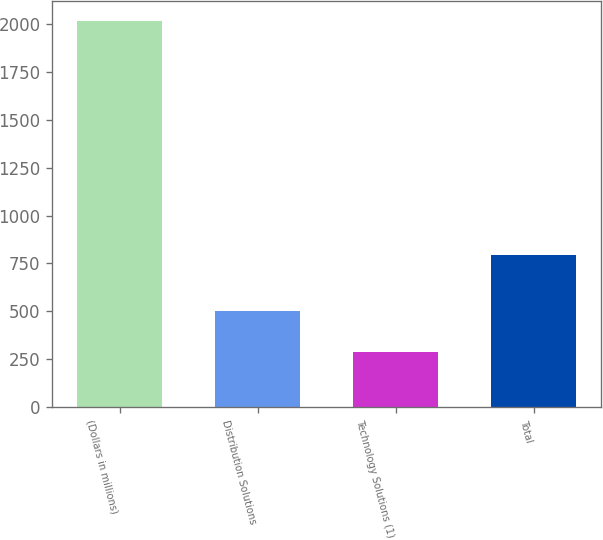Convert chart. <chart><loc_0><loc_0><loc_500><loc_500><bar_chart><fcel>(Dollars in millions)<fcel>Distribution Solutions<fcel>Technology Solutions (1)<fcel>Total<nl><fcel>2018<fcel>503<fcel>289<fcel>792<nl></chart> 